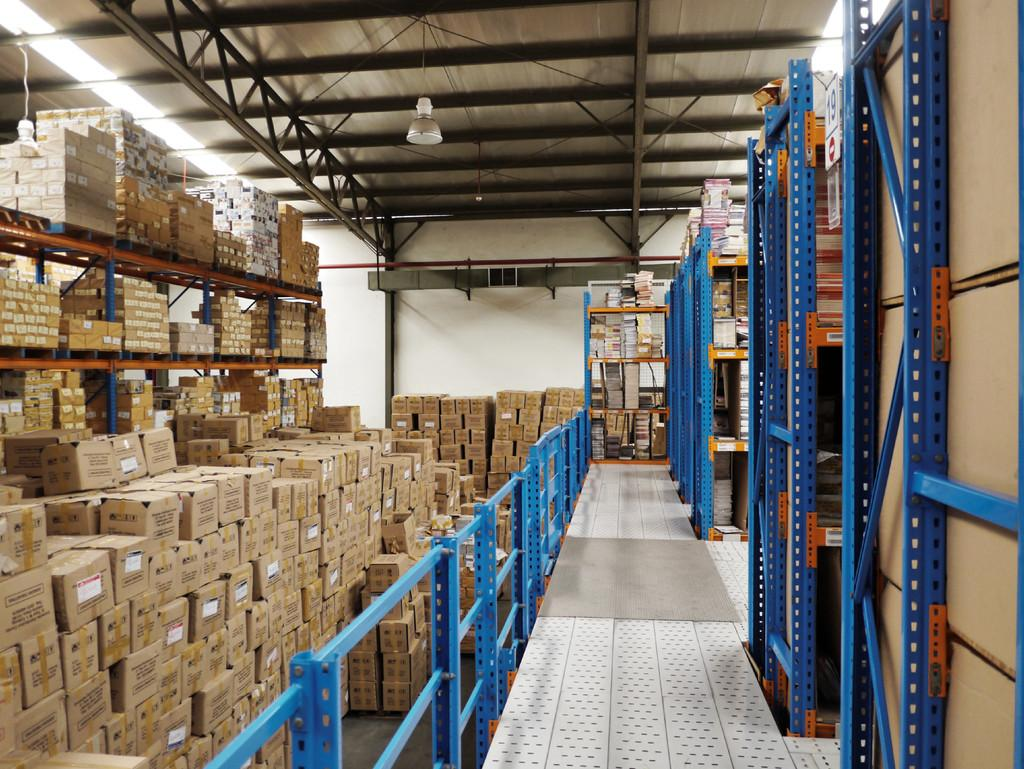What objects are present in the image? There are boxes in the image. What can be seen on the right side of the image? There are cracks on the right side of the image. Where is the light located in the image? There is a light in the top left of the image, and another light at the top of the image. What type of bird can be seen flying in the image? There is no bird present in the image. What time of day is depicted in the image? The time of day cannot be determined from the image. 